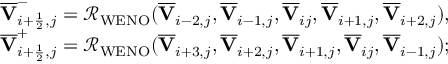<formula> <loc_0><loc_0><loc_500><loc_500>\begin{array} { r } { \overline { V } _ { i + \frac { 1 } { 2 } , j } ^ { - } = \mathcal { R } _ { W E N O } ( \overline { V } _ { i - 2 , j } , \overline { V } _ { i - 1 , j } , \overline { V } _ { i j } , \overline { V } _ { i + 1 , j } , \overline { V } _ { i + 2 , j } ) , } \\ { \overline { V } _ { i + \frac { 1 } { 2 } , j } ^ { + } = \mathcal { R } _ { W E N O } ( \overline { V } _ { i + 3 , j } , \overline { V } _ { i + 2 , j } , \overline { V } _ { i + 1 , j } , \overline { V } _ { i j } , \overline { V } _ { i - 1 , j } ) ; } \end{array}</formula> 